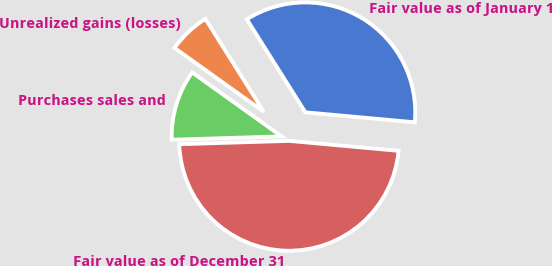Convert chart to OTSL. <chart><loc_0><loc_0><loc_500><loc_500><pie_chart><fcel>Fair value as of January 1<fcel>Unrealized gains (losses)<fcel>Purchases sales and<fcel>Fair value as of December 31<nl><fcel>35.38%<fcel>6.18%<fcel>10.37%<fcel>48.06%<nl></chart> 